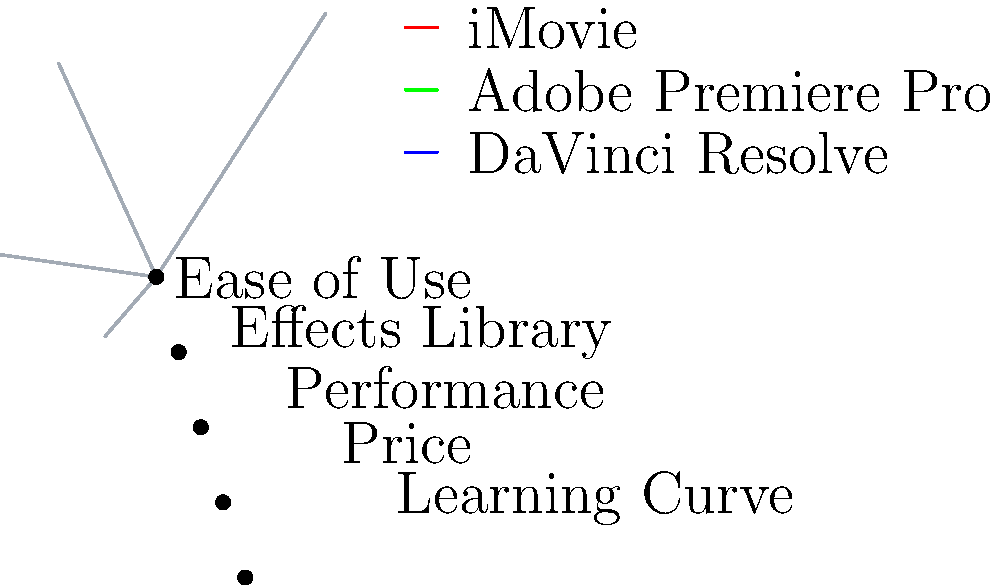Based on the radar chart comparing different video editing software options, which software would you recommend to your introverted friend who is just starting their YouTube channel? To recommend the best video editing software for your introverted friend who is new to YouTube, let's analyze the radar chart:

1. Ease of Use:
   iMovie (red) scores highest, followed by DaVinci Resolve (blue), then Adobe Premiere Pro (green).

2. Effects Library:
   Adobe Premiere Pro has the most extensive library, followed by DaVinci Resolve, then iMovie.

3. Performance:
   DaVinci Resolve performs best, followed by Adobe Premiere Pro, then iMovie.

4. Price:
   iMovie is the most affordable, followed by DaVinci Resolve, then Adobe Premiere Pro.

5. Learning Curve:
   iMovie has the easiest learning curve, followed by DaVinci Resolve, then Adobe Premiere Pro.

For a beginner YouTuber, the most important factors are ease of use, learning curve, and price. iMovie excels in these areas, making it the best choice for your introverted friend who is just starting out. It's user-friendly, affordable (often free on Mac devices), and has a gentle learning curve.

While iMovie may have fewer effects and lower performance compared to the other options, these factors are less critical for a beginner. As your friend gains experience and confidence, they can later transition to more advanced software like DaVinci Resolve or Adobe Premiere Pro.
Answer: iMovie 